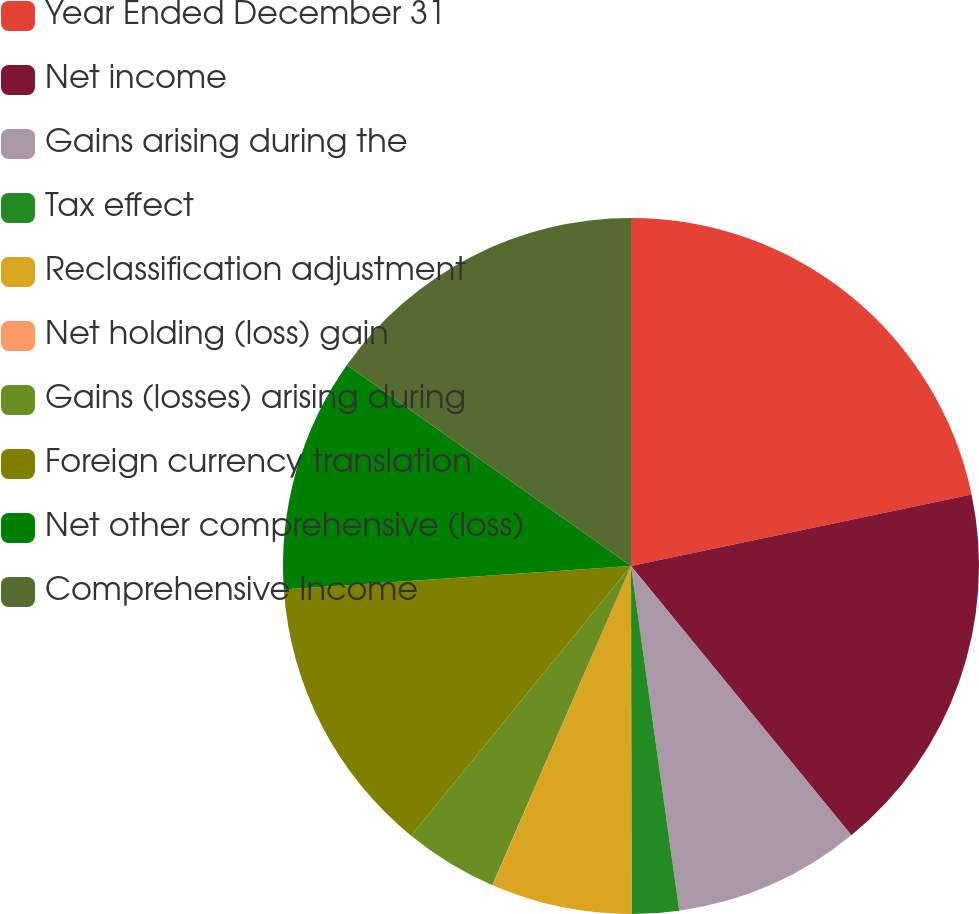Convert chart to OTSL. <chart><loc_0><loc_0><loc_500><loc_500><pie_chart><fcel>Year Ended December 31<fcel>Net income<fcel>Gains arising during the<fcel>Tax effect<fcel>Reclassification adjustment<fcel>Net holding (loss) gain<fcel>Gains (losses) arising during<fcel>Foreign currency translation<fcel>Net other comprehensive (loss)<fcel>Comprehensive Income<nl><fcel>21.71%<fcel>17.37%<fcel>8.7%<fcel>2.19%<fcel>6.53%<fcel>0.02%<fcel>4.36%<fcel>13.04%<fcel>10.87%<fcel>15.2%<nl></chart> 